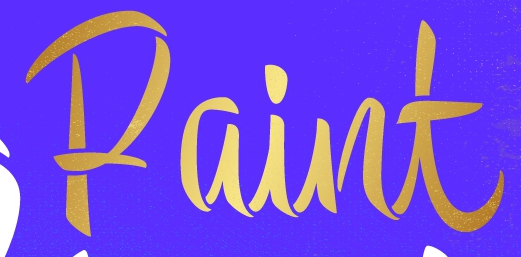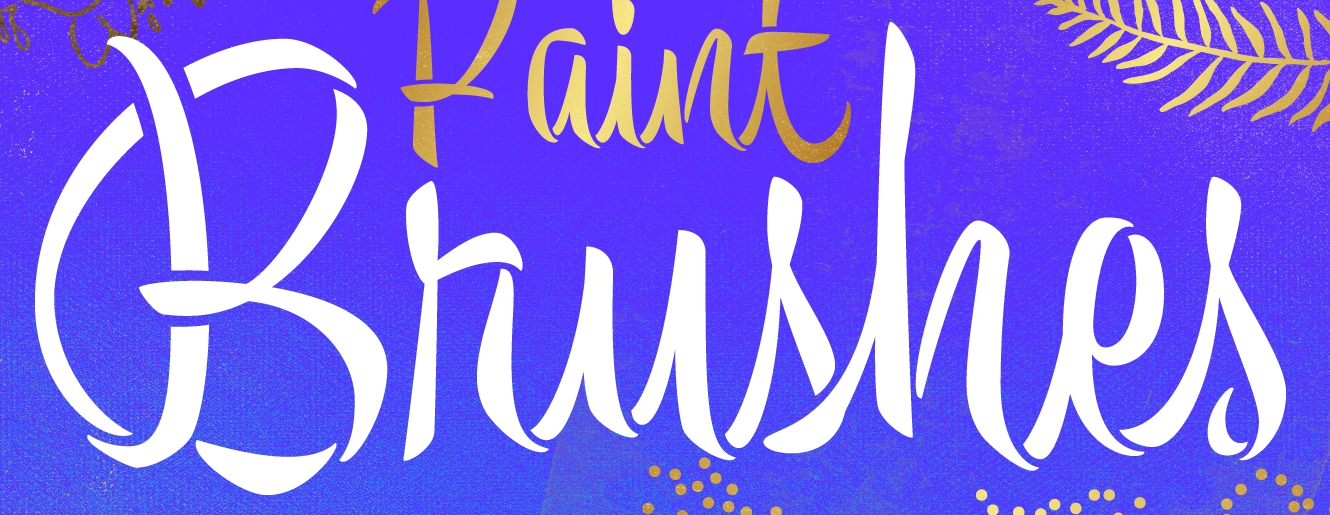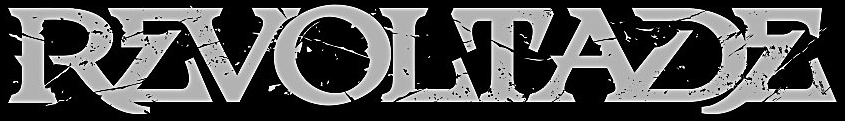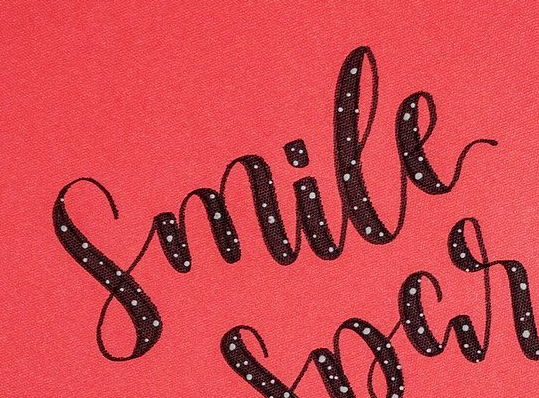What text is displayed in these images sequentially, separated by a semicolon? Paint; Brushes; REVOLTADE; Smile 